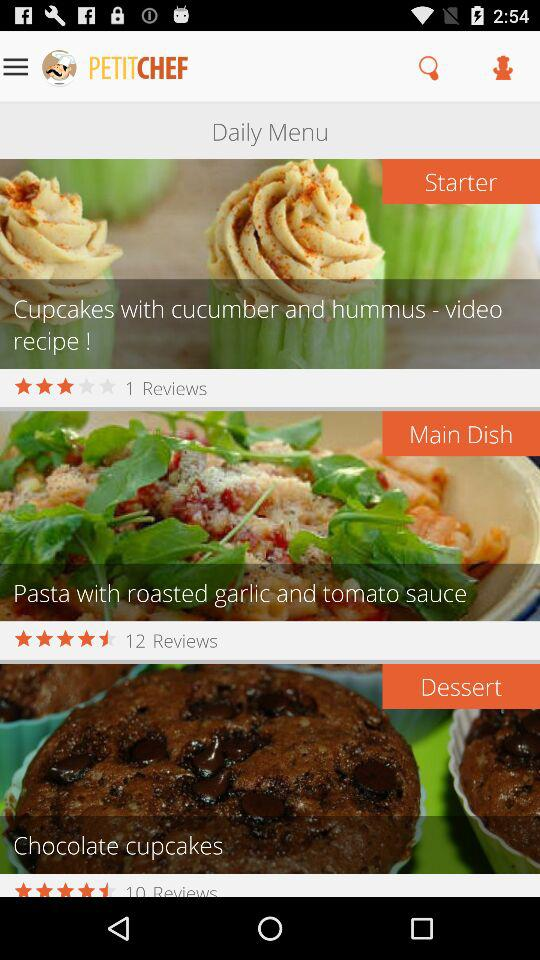What is the rating for the starter? The rating for the starter is 3 stars. 